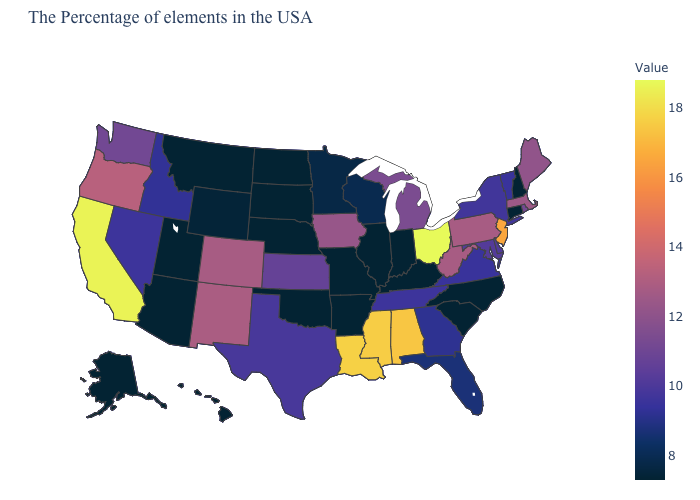Which states hav the highest value in the West?
Keep it brief. California. Among the states that border Rhode Island , does Massachusetts have the lowest value?
Give a very brief answer. No. Does the map have missing data?
Answer briefly. No. 